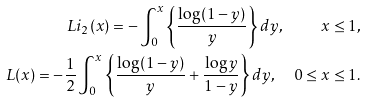<formula> <loc_0><loc_0><loc_500><loc_500>L i _ { 2 } ( x ) = - \int _ { 0 } ^ { x } \left \{ \frac { \log ( 1 - y ) } { y } \right \} d y , \quad x \leq 1 , \\ L ( x ) = - \frac { 1 } { 2 } \int _ { 0 } ^ { x } \left \{ \frac { \log ( 1 - y ) } { y } + \frac { \log y } { 1 - y } \right \} d y , \quad 0 \leq x \leq 1 .</formula> 